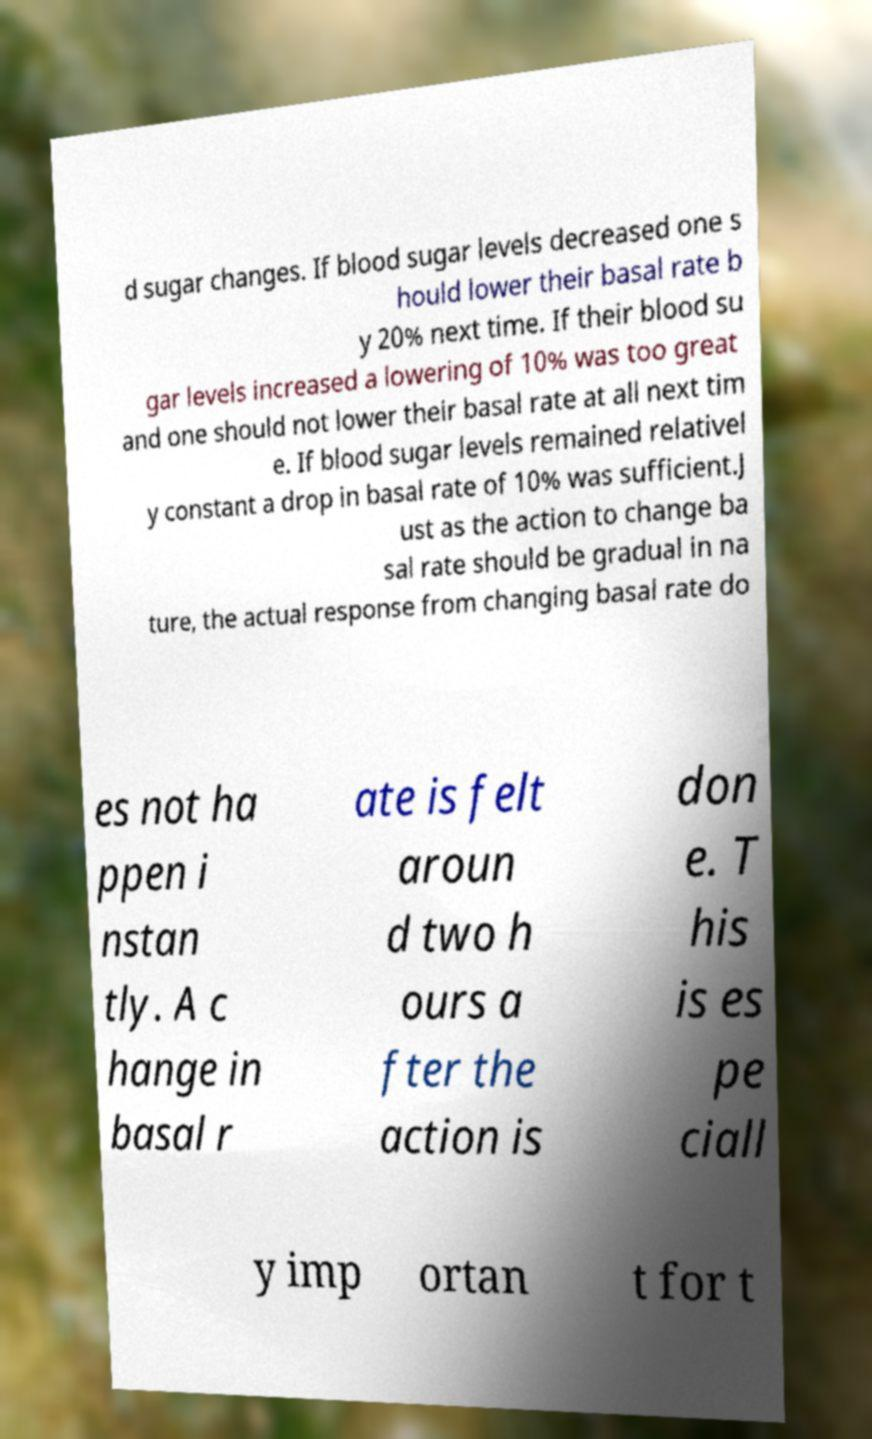Could you extract and type out the text from this image? d sugar changes. If blood sugar levels decreased one s hould lower their basal rate b y 20% next time. If their blood su gar levels increased a lowering of 10% was too great and one should not lower their basal rate at all next tim e. If blood sugar levels remained relativel y constant a drop in basal rate of 10% was sufficient.J ust as the action to change ba sal rate should be gradual in na ture, the actual response from changing basal rate do es not ha ppen i nstan tly. A c hange in basal r ate is felt aroun d two h ours a fter the action is don e. T his is es pe ciall y imp ortan t for t 